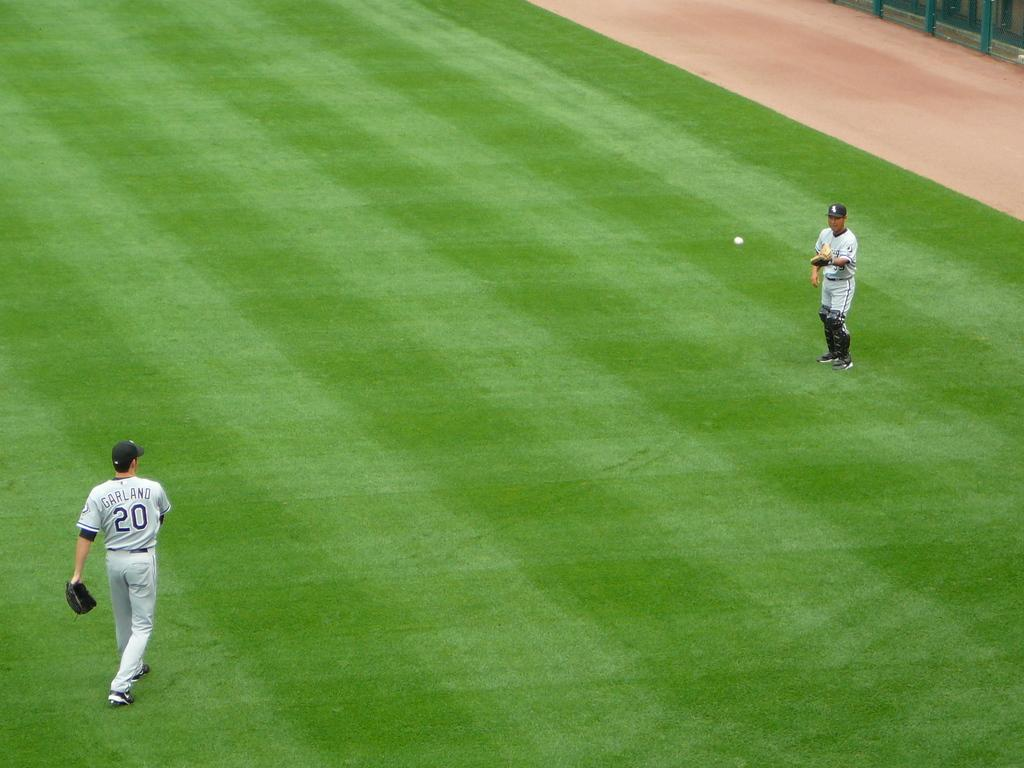<image>
Write a terse but informative summary of the picture. Baseball player wearing a number 20 on his jersey. 